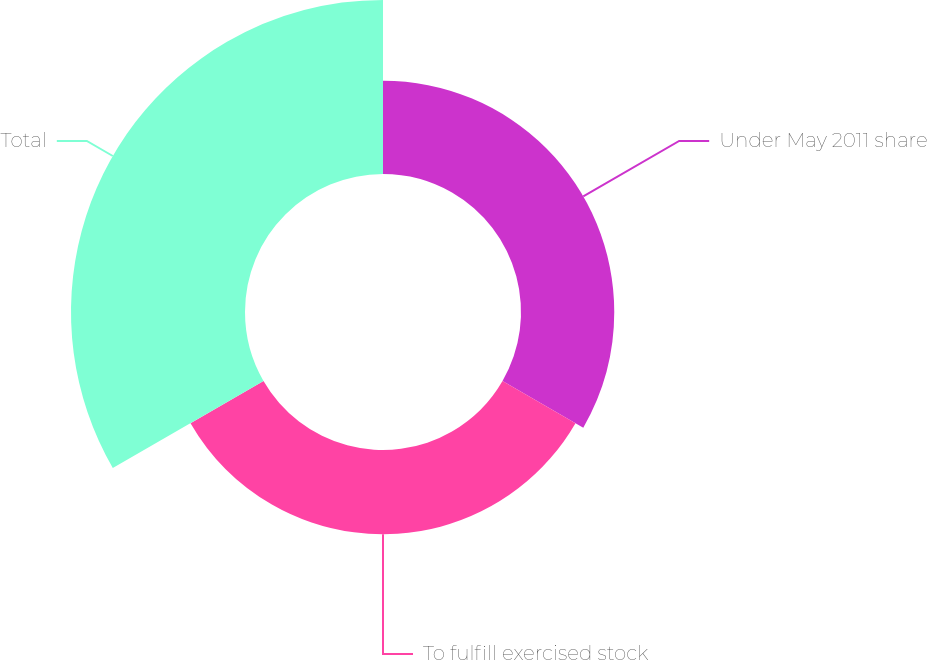Convert chart. <chart><loc_0><loc_0><loc_500><loc_500><pie_chart><fcel>Under May 2011 share<fcel>To fulfill exercised stock<fcel>Total<nl><fcel>26.53%<fcel>23.97%<fcel>49.5%<nl></chart> 